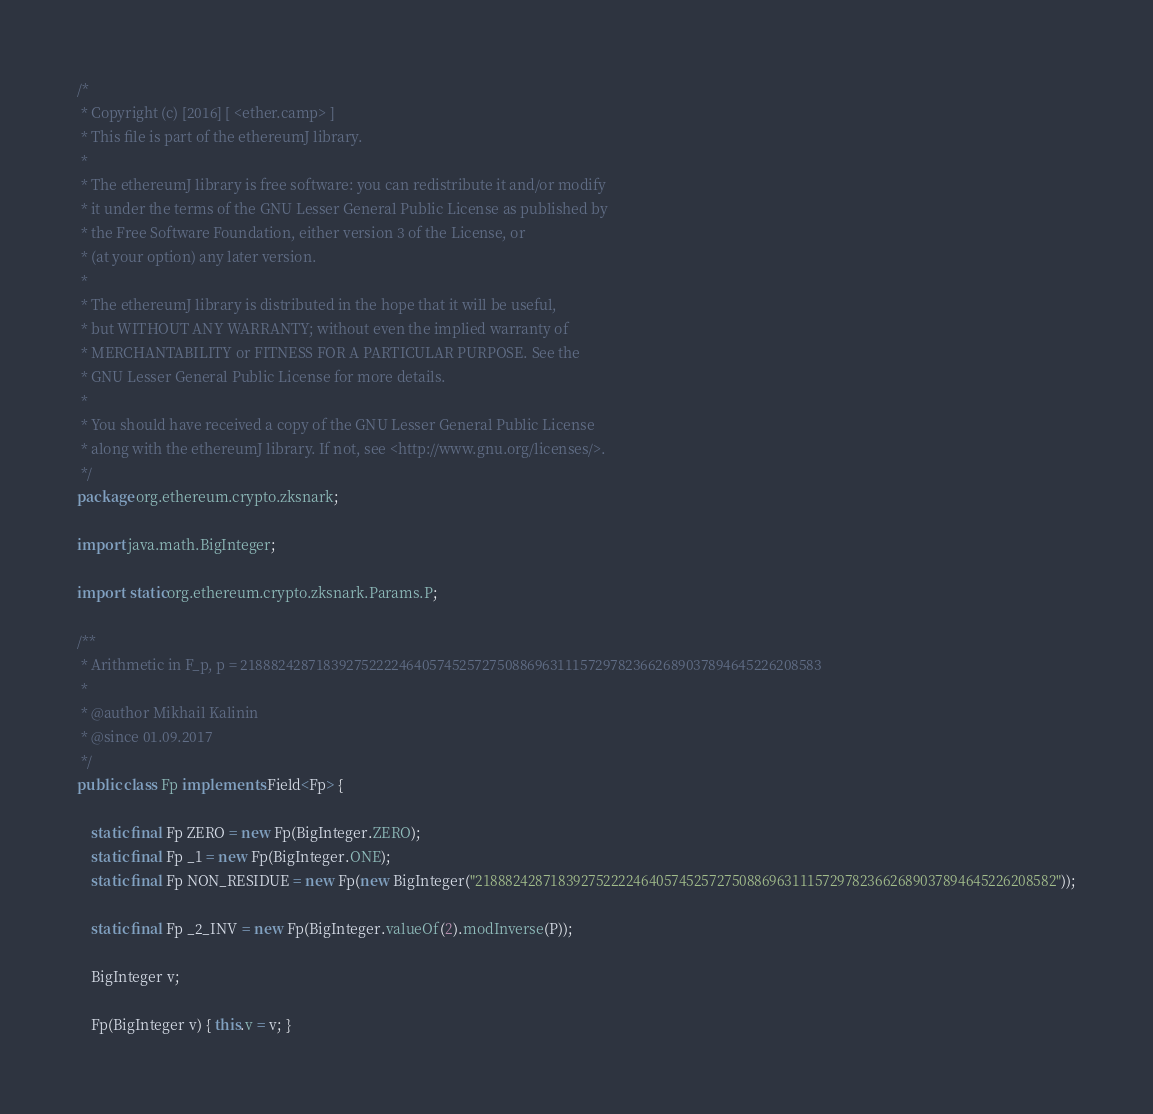<code> <loc_0><loc_0><loc_500><loc_500><_Java_>/*
 * Copyright (c) [2016] [ <ether.camp> ]
 * This file is part of the ethereumJ library.
 *
 * The ethereumJ library is free software: you can redistribute it and/or modify
 * it under the terms of the GNU Lesser General Public License as published by
 * the Free Software Foundation, either version 3 of the License, or
 * (at your option) any later version.
 *
 * The ethereumJ library is distributed in the hope that it will be useful,
 * but WITHOUT ANY WARRANTY; without even the implied warranty of
 * MERCHANTABILITY or FITNESS FOR A PARTICULAR PURPOSE. See the
 * GNU Lesser General Public License for more details.
 *
 * You should have received a copy of the GNU Lesser General Public License
 * along with the ethereumJ library. If not, see <http://www.gnu.org/licenses/>.
 */
package org.ethereum.crypto.zksnark;

import java.math.BigInteger;

import static org.ethereum.crypto.zksnark.Params.P;

/**
 * Arithmetic in F_p, p = 21888242871839275222246405745257275088696311157297823662689037894645226208583
 *
 * @author Mikhail Kalinin
 * @since 01.09.2017
 */
public class Fp implements Field<Fp> {

    static final Fp ZERO = new Fp(BigInteger.ZERO);
    static final Fp _1 = new Fp(BigInteger.ONE);
    static final Fp NON_RESIDUE = new Fp(new BigInteger("21888242871839275222246405745257275088696311157297823662689037894645226208582"));

    static final Fp _2_INV = new Fp(BigInteger.valueOf(2).modInverse(P));

    BigInteger v;

    Fp(BigInteger v) { this.v = v; }
</code> 